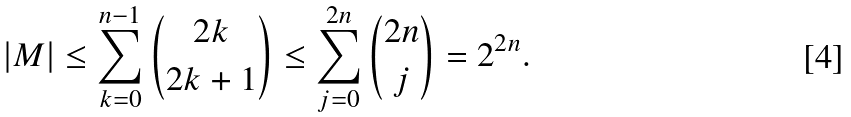<formula> <loc_0><loc_0><loc_500><loc_500>| M | \leq \sum ^ { n - 1 } _ { k = 0 } \binom { 2 k } { 2 k + 1 } \leq \sum ^ { 2 n } _ { j = 0 } \binom { 2 n } { j } = 2 ^ { 2 n } .</formula> 